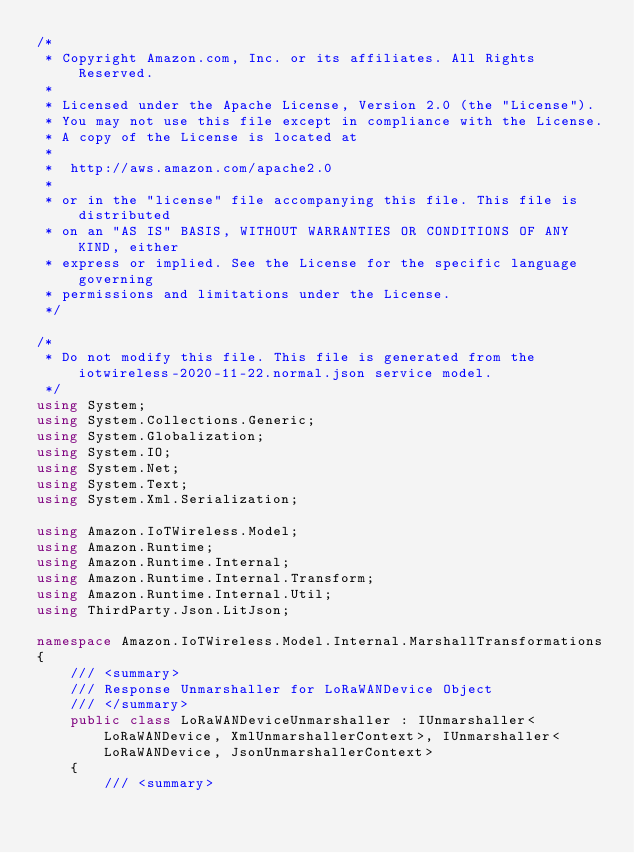<code> <loc_0><loc_0><loc_500><loc_500><_C#_>/*
 * Copyright Amazon.com, Inc. or its affiliates. All Rights Reserved.
 * 
 * Licensed under the Apache License, Version 2.0 (the "License").
 * You may not use this file except in compliance with the License.
 * A copy of the License is located at
 * 
 *  http://aws.amazon.com/apache2.0
 * 
 * or in the "license" file accompanying this file. This file is distributed
 * on an "AS IS" BASIS, WITHOUT WARRANTIES OR CONDITIONS OF ANY KIND, either
 * express or implied. See the License for the specific language governing
 * permissions and limitations under the License.
 */

/*
 * Do not modify this file. This file is generated from the iotwireless-2020-11-22.normal.json service model.
 */
using System;
using System.Collections.Generic;
using System.Globalization;
using System.IO;
using System.Net;
using System.Text;
using System.Xml.Serialization;

using Amazon.IoTWireless.Model;
using Amazon.Runtime;
using Amazon.Runtime.Internal;
using Amazon.Runtime.Internal.Transform;
using Amazon.Runtime.Internal.Util;
using ThirdParty.Json.LitJson;

namespace Amazon.IoTWireless.Model.Internal.MarshallTransformations
{
    /// <summary>
    /// Response Unmarshaller for LoRaWANDevice Object
    /// </summary>  
    public class LoRaWANDeviceUnmarshaller : IUnmarshaller<LoRaWANDevice, XmlUnmarshallerContext>, IUnmarshaller<LoRaWANDevice, JsonUnmarshallerContext>
    {
        /// <summary></code> 